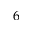<formula> <loc_0><loc_0><loc_500><loc_500>6</formula> 